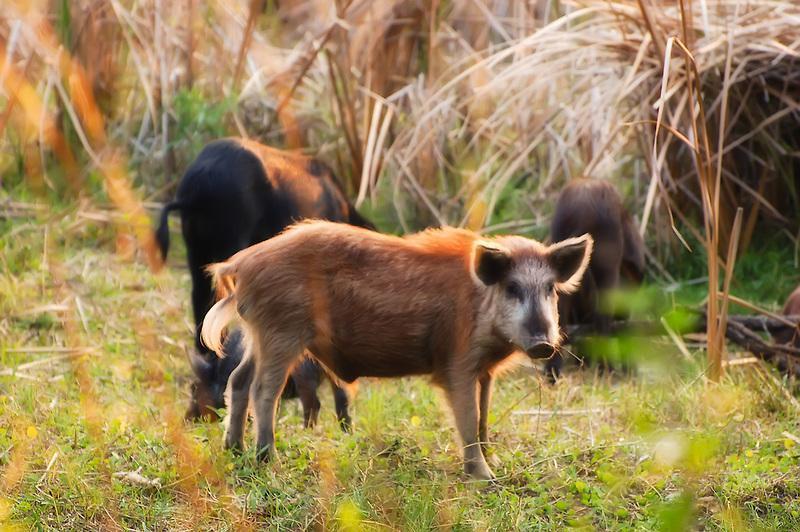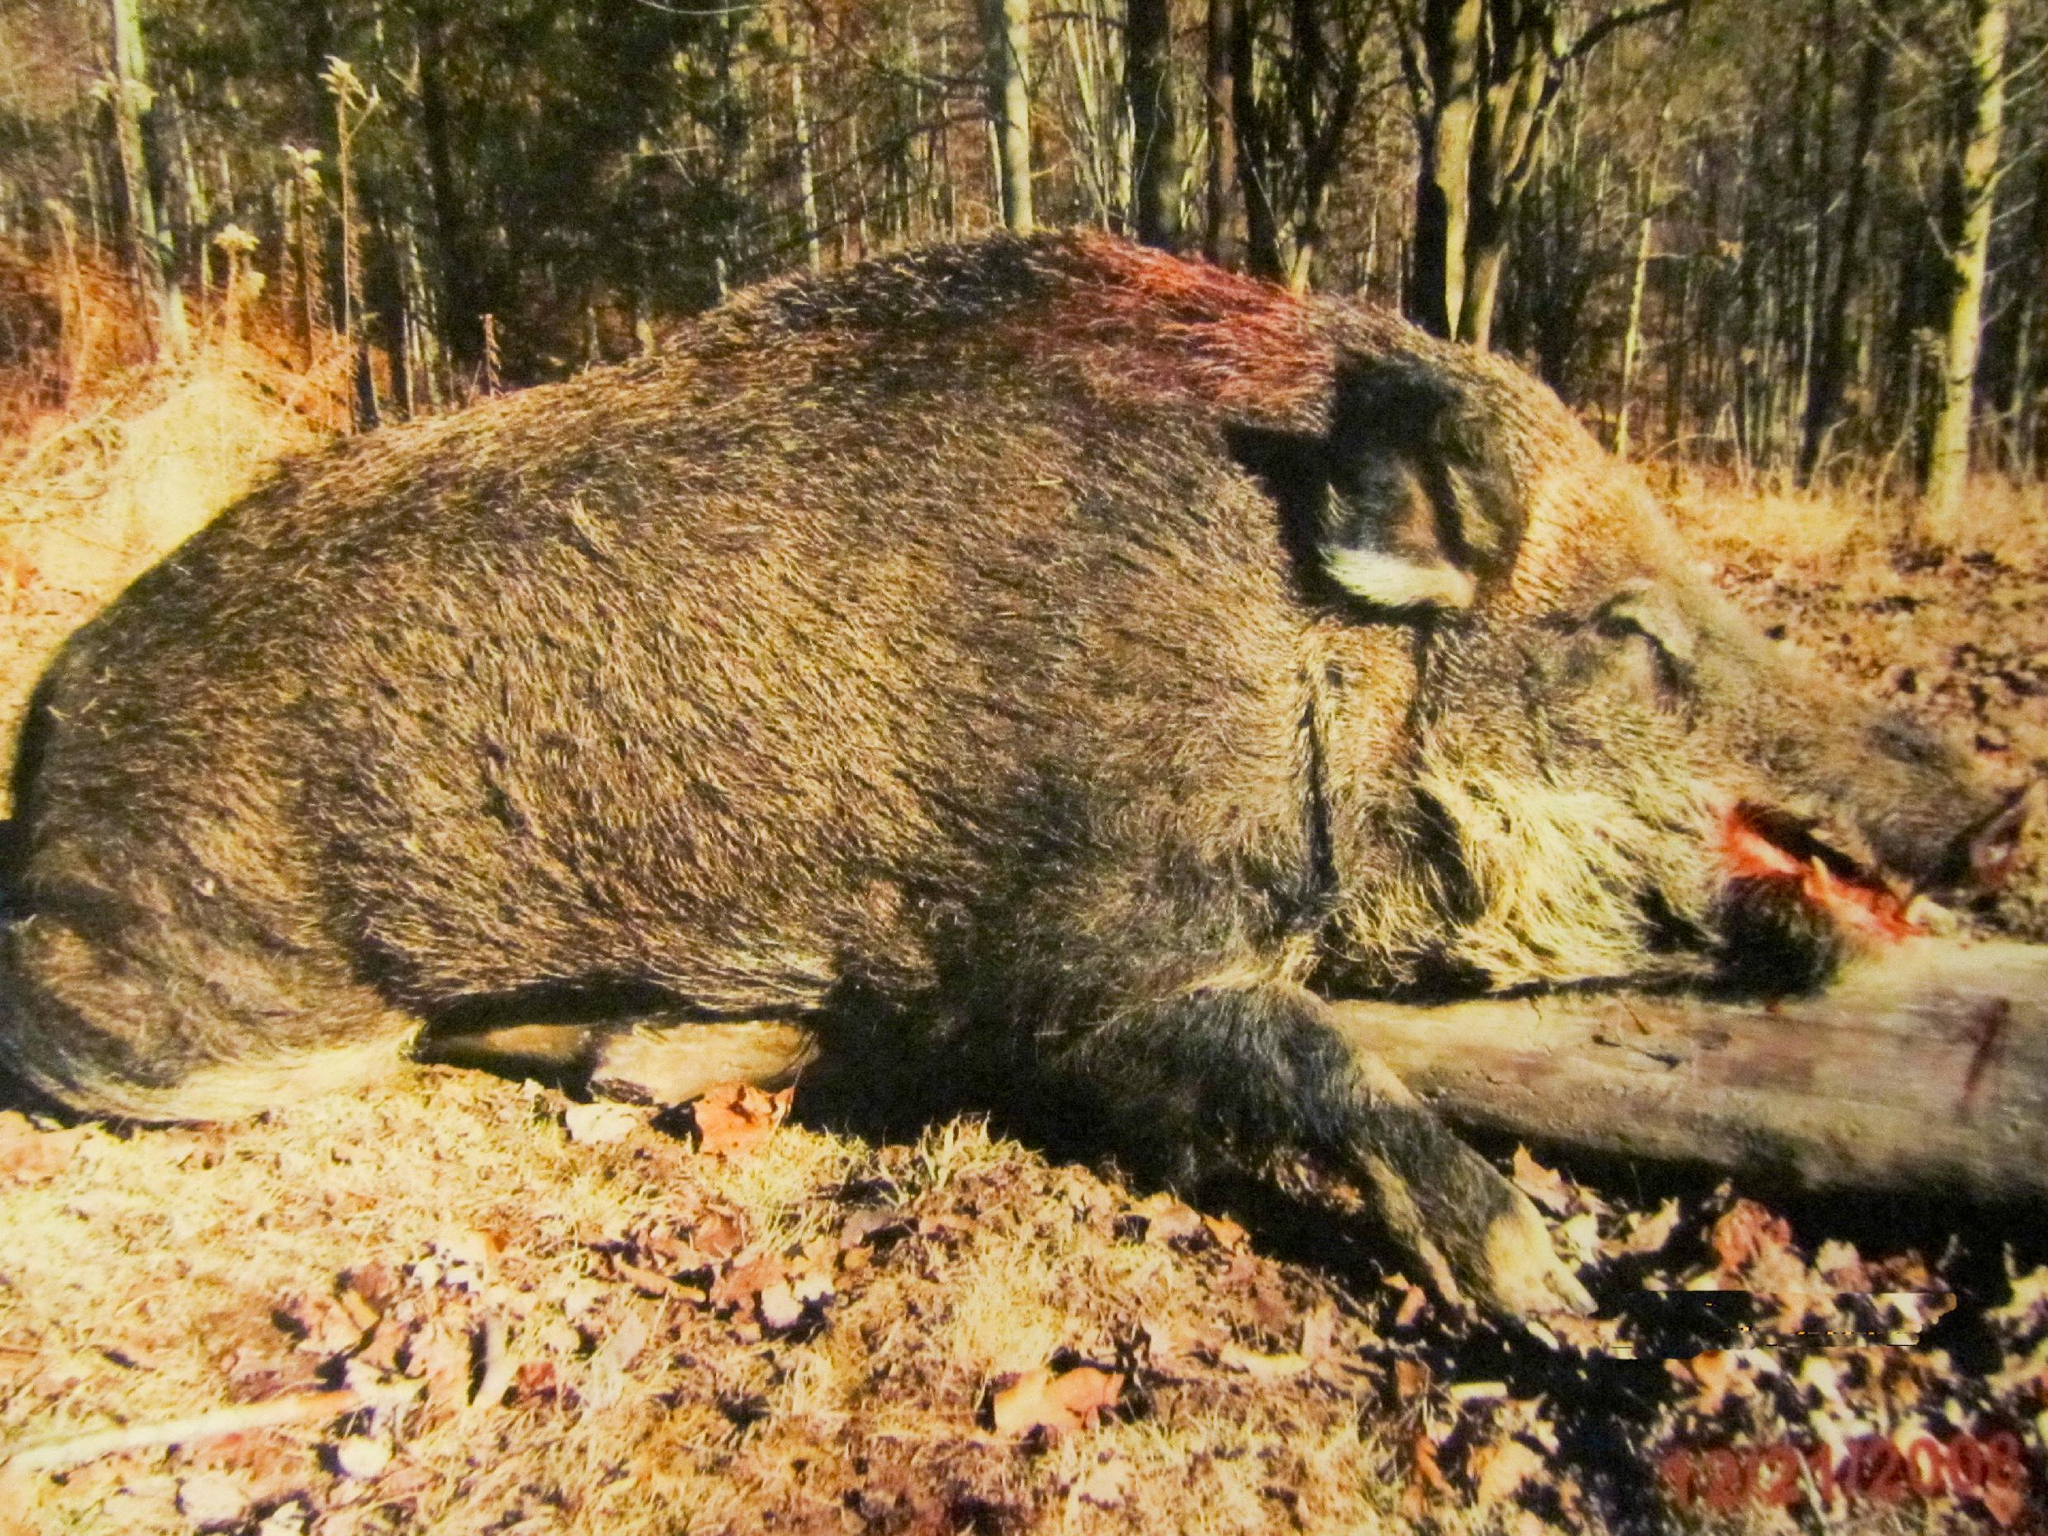The first image is the image on the left, the second image is the image on the right. For the images displayed, is the sentence "In one image, the animals are standing on grass that is green." factually correct? Answer yes or no. Yes. The first image is the image on the left, the second image is the image on the right. Analyze the images presented: Is the assertion "The pigs are standing on yellow leaves in one image and not in the other." valid? Answer yes or no. No. 